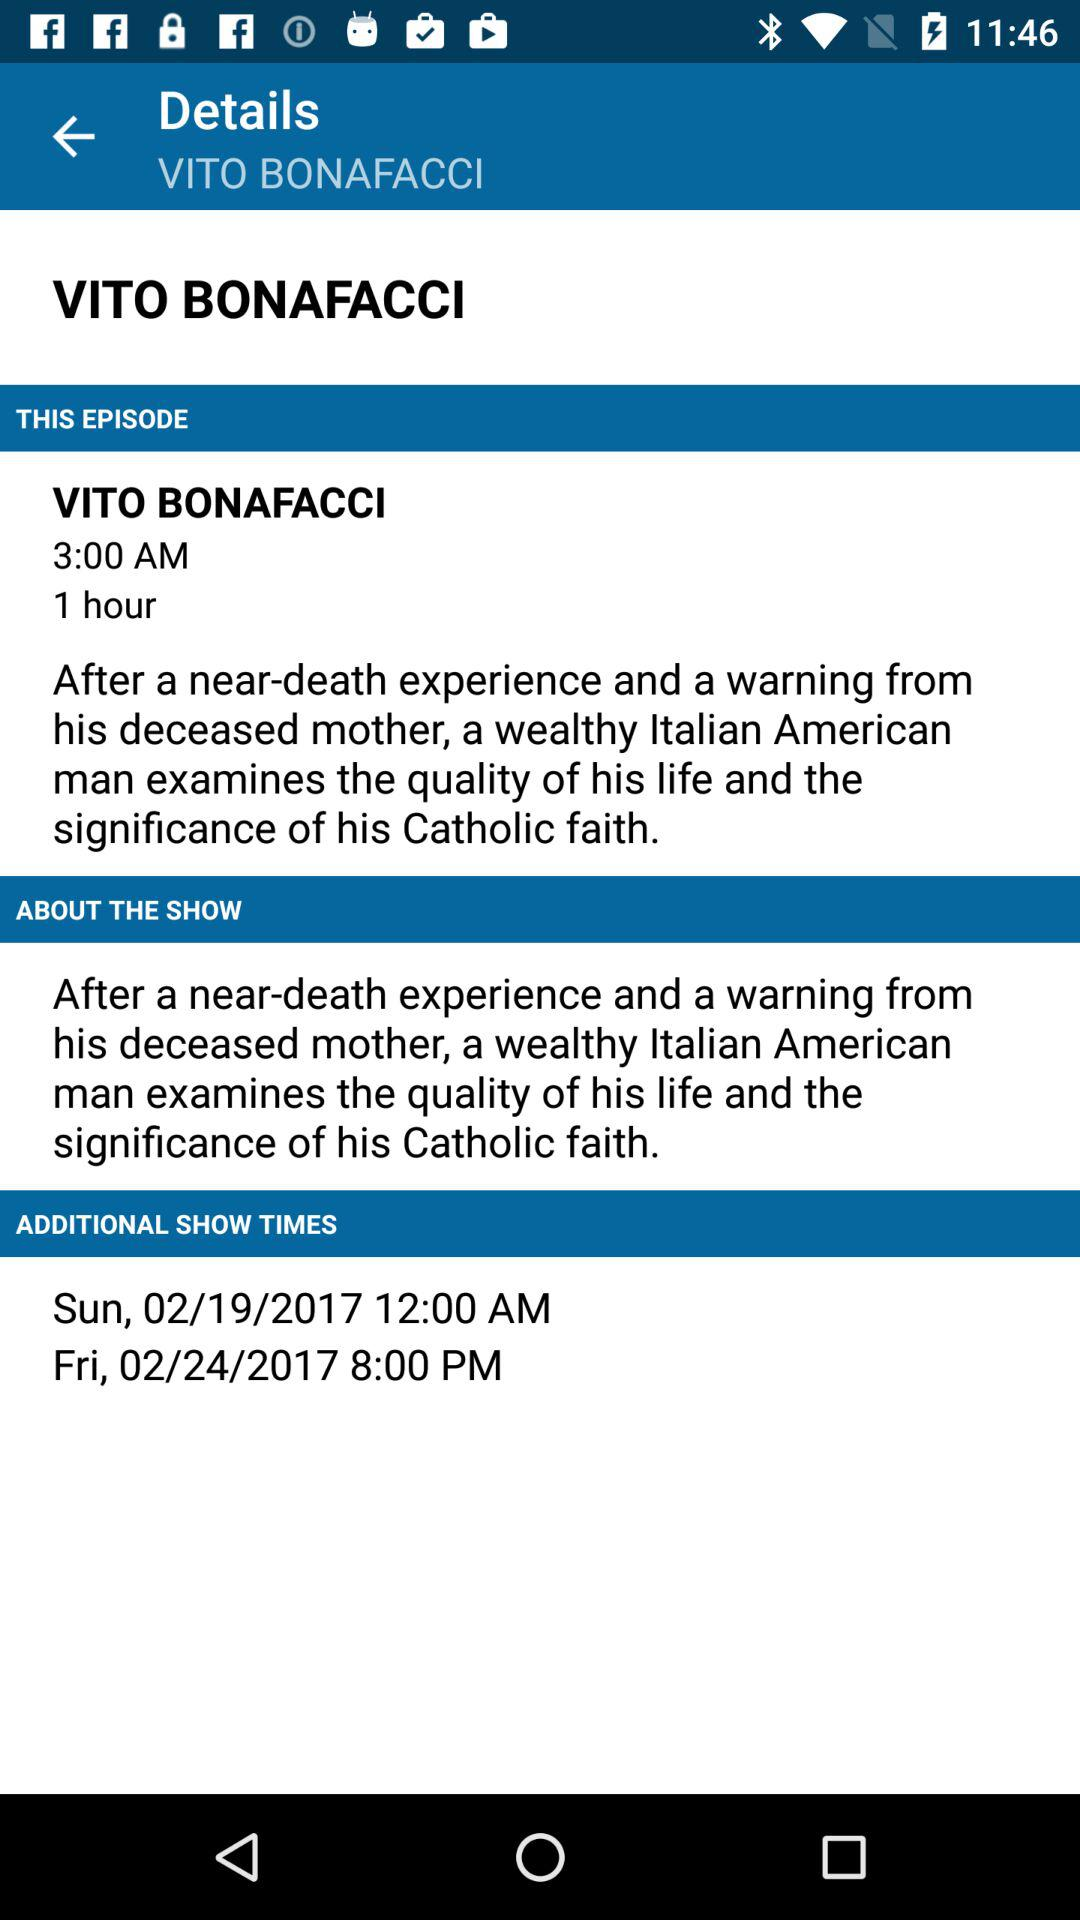What is the show time on Sunday, February 19, 2017? The show time on Sunday, February 19, 2017 is 12:00 AM. 